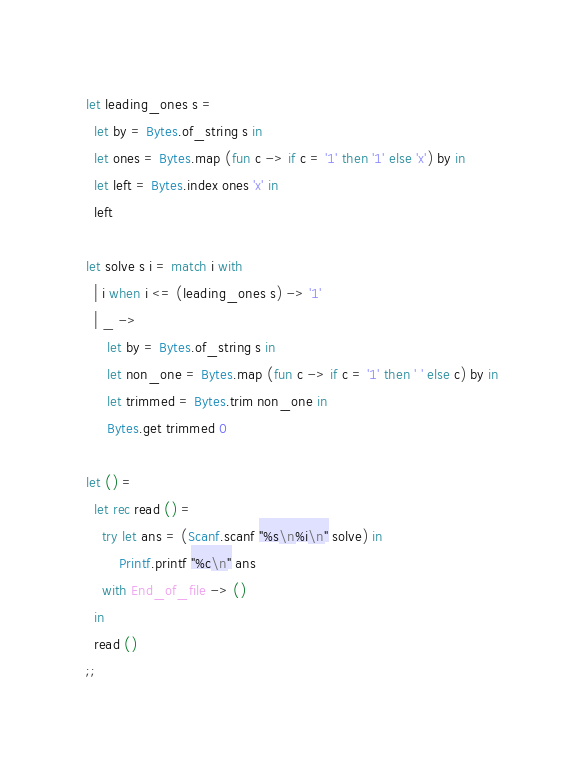<code> <loc_0><loc_0><loc_500><loc_500><_OCaml_>let leading_ones s =
  let by = Bytes.of_string s in
  let ones = Bytes.map (fun c -> if c = '1' then '1' else 'x') by in
  let left = Bytes.index ones 'x' in
  left

let solve s i = match i with
  | i when i <= (leading_ones s) -> '1'
  | _ ->
     let by = Bytes.of_string s in
     let non_one = Bytes.map (fun c -> if c = '1' then ' ' else c) by in
     let trimmed = Bytes.trim non_one in
     Bytes.get trimmed 0

let () =
  let rec read () =
    try let ans = (Scanf.scanf "%s\n%i\n" solve) in
        Printf.printf "%c\n" ans
    with End_of_file -> ()
  in
  read ()
;;
</code> 